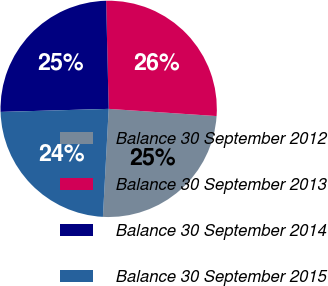Convert chart to OTSL. <chart><loc_0><loc_0><loc_500><loc_500><pie_chart><fcel>Balance 30 September 2012<fcel>Balance 30 September 2013<fcel>Balance 30 September 2014<fcel>Balance 30 September 2015<nl><fcel>24.79%<fcel>26.44%<fcel>25.07%<fcel>23.7%<nl></chart> 